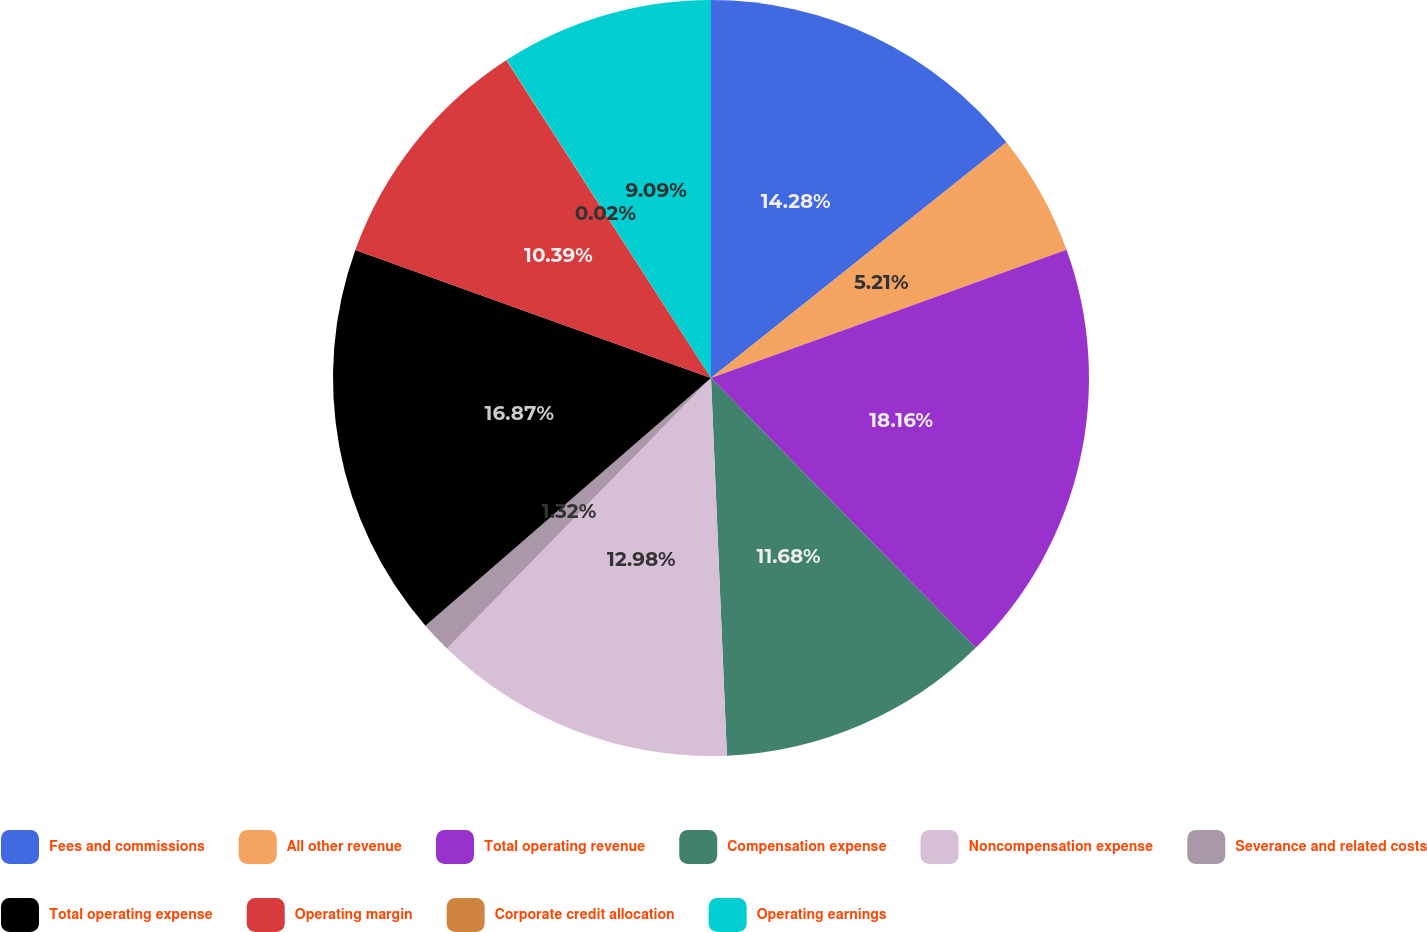<chart> <loc_0><loc_0><loc_500><loc_500><pie_chart><fcel>Fees and commissions<fcel>All other revenue<fcel>Total operating revenue<fcel>Compensation expense<fcel>Noncompensation expense<fcel>Severance and related costs<fcel>Total operating expense<fcel>Operating margin<fcel>Corporate credit allocation<fcel>Operating earnings<nl><fcel>14.28%<fcel>5.21%<fcel>18.16%<fcel>11.68%<fcel>12.98%<fcel>1.32%<fcel>16.87%<fcel>10.39%<fcel>0.02%<fcel>9.09%<nl></chart> 